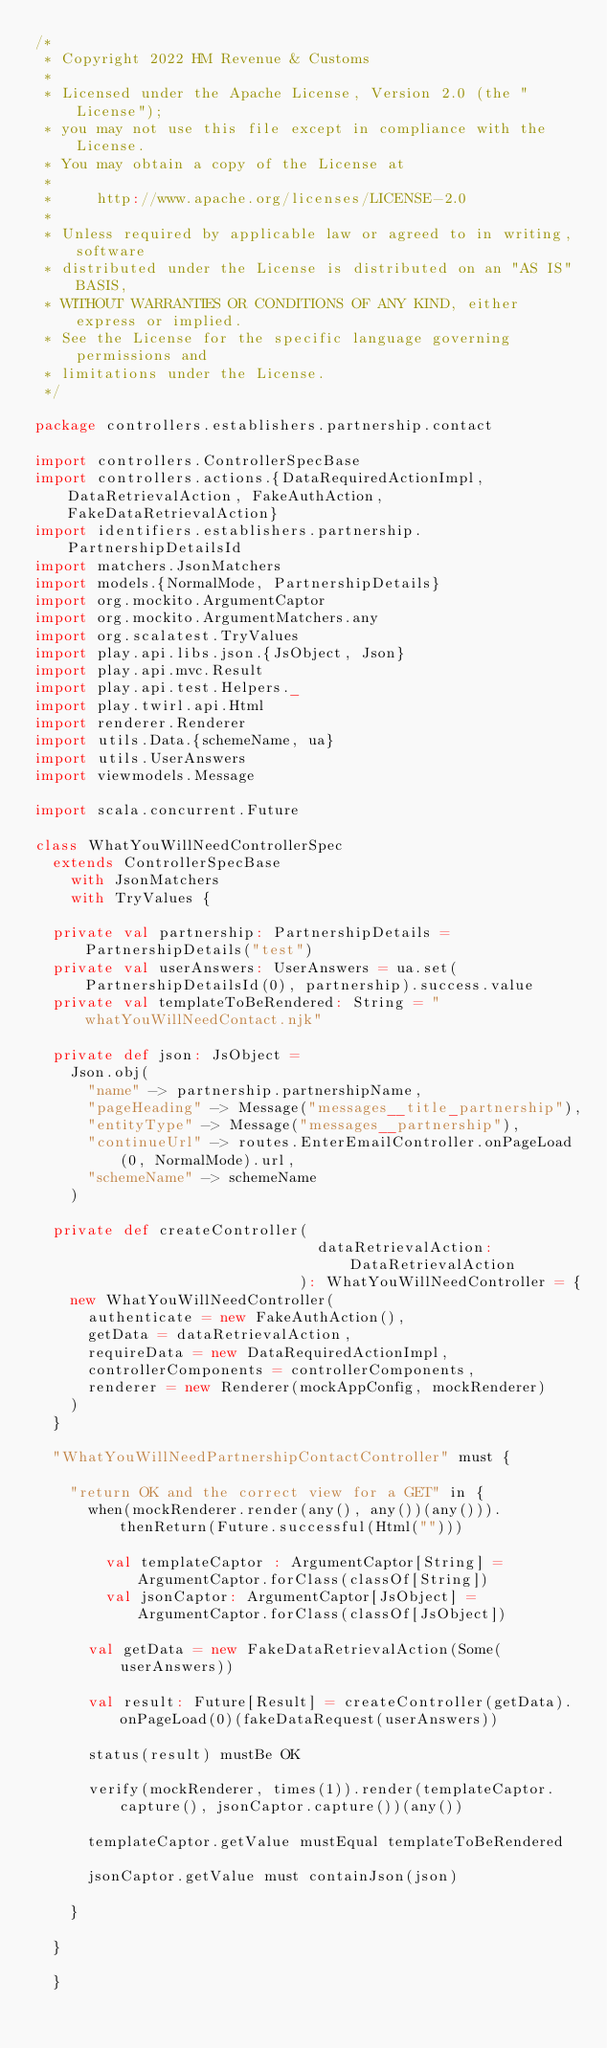<code> <loc_0><loc_0><loc_500><loc_500><_Scala_>/*
 * Copyright 2022 HM Revenue & Customs
 *
 * Licensed under the Apache License, Version 2.0 (the "License");
 * you may not use this file except in compliance with the License.
 * You may obtain a copy of the License at
 *
 *     http://www.apache.org/licenses/LICENSE-2.0
 *
 * Unless required by applicable law or agreed to in writing, software
 * distributed under the License is distributed on an "AS IS" BASIS,
 * WITHOUT WARRANTIES OR CONDITIONS OF ANY KIND, either express or implied.
 * See the License for the specific language governing permissions and
 * limitations under the License.
 */

package controllers.establishers.partnership.contact

import controllers.ControllerSpecBase
import controllers.actions.{DataRequiredActionImpl, DataRetrievalAction, FakeAuthAction, FakeDataRetrievalAction}
import identifiers.establishers.partnership.PartnershipDetailsId
import matchers.JsonMatchers
import models.{NormalMode, PartnershipDetails}
import org.mockito.ArgumentCaptor
import org.mockito.ArgumentMatchers.any
import org.scalatest.TryValues
import play.api.libs.json.{JsObject, Json}
import play.api.mvc.Result
import play.api.test.Helpers._
import play.twirl.api.Html
import renderer.Renderer
import utils.Data.{schemeName, ua}
import utils.UserAnswers
import viewmodels.Message

import scala.concurrent.Future

class WhatYouWillNeedControllerSpec
  extends ControllerSpecBase
    with JsonMatchers
    with TryValues {

  private val partnership: PartnershipDetails = PartnershipDetails("test")
  private val userAnswers: UserAnswers = ua.set(PartnershipDetailsId(0), partnership).success.value
  private val templateToBeRendered: String = "whatYouWillNeedContact.njk"

  private def json: JsObject =
    Json.obj(
      "name" -> partnership.partnershipName,
      "pageHeading" -> Message("messages__title_partnership"),
      "entityType" -> Message("messages__partnership"),
      "continueUrl" -> routes.EnterEmailController.onPageLoad(0, NormalMode).url,
      "schemeName" -> schemeName
    )

  private def createController(
                                dataRetrievalAction: DataRetrievalAction
                              ): WhatYouWillNeedController = {
    new WhatYouWillNeedController(
      authenticate = new FakeAuthAction(),
      getData = dataRetrievalAction,
      requireData = new DataRequiredActionImpl,
      controllerComponents = controllerComponents,
      renderer = new Renderer(mockAppConfig, mockRenderer)
    )
  }

  "WhatYouWillNeedPartnershipContactController" must {

    "return OK and the correct view for a GET" in {
      when(mockRenderer.render(any(), any())(any())).thenReturn(Future.successful(Html("")))

        val templateCaptor : ArgumentCaptor[String] = ArgumentCaptor.forClass(classOf[String])
        val jsonCaptor: ArgumentCaptor[JsObject] = ArgumentCaptor.forClass(classOf[JsObject])

      val getData = new FakeDataRetrievalAction(Some(userAnswers))

      val result: Future[Result] = createController(getData).onPageLoad(0)(fakeDataRequest(userAnswers))

      status(result) mustBe OK

      verify(mockRenderer, times(1)).render(templateCaptor.capture(), jsonCaptor.capture())(any())

      templateCaptor.getValue mustEqual templateToBeRendered

      jsonCaptor.getValue must containJson(json)

    }

  }

  }
</code> 